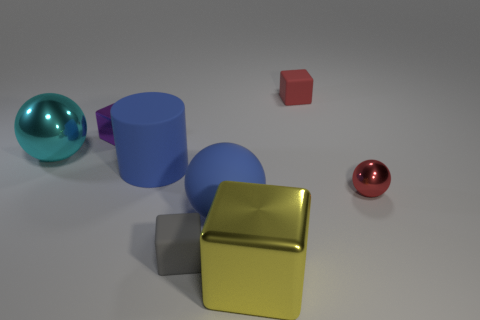Are there fewer blue matte cylinders that are to the right of the tiny gray matte block than rubber cubes?
Make the answer very short. Yes. Are there fewer metallic objects in front of the big yellow metallic thing than big rubber cylinders that are left of the red cube?
Your answer should be compact. Yes. How many spheres are either purple rubber things or cyan shiny objects?
Give a very brief answer. 1. Are the big ball to the right of the purple metal cube and the sphere behind the big matte cylinder made of the same material?
Give a very brief answer. No. What is the shape of the cyan object that is the same size as the yellow thing?
Provide a succinct answer. Sphere. What number of other things are there of the same color as the rubber ball?
Keep it short and to the point. 1. What number of blue objects are rubber things or metal cubes?
Provide a succinct answer. 2. Do the tiny metallic thing that is in front of the cyan metallic sphere and the blue matte object that is behind the large rubber sphere have the same shape?
Give a very brief answer. No. What number of other objects are the same material as the big yellow thing?
Your answer should be compact. 3. Is there a matte thing behind the metal block behind the big object that is left of the purple metallic object?
Your answer should be very brief. Yes. 